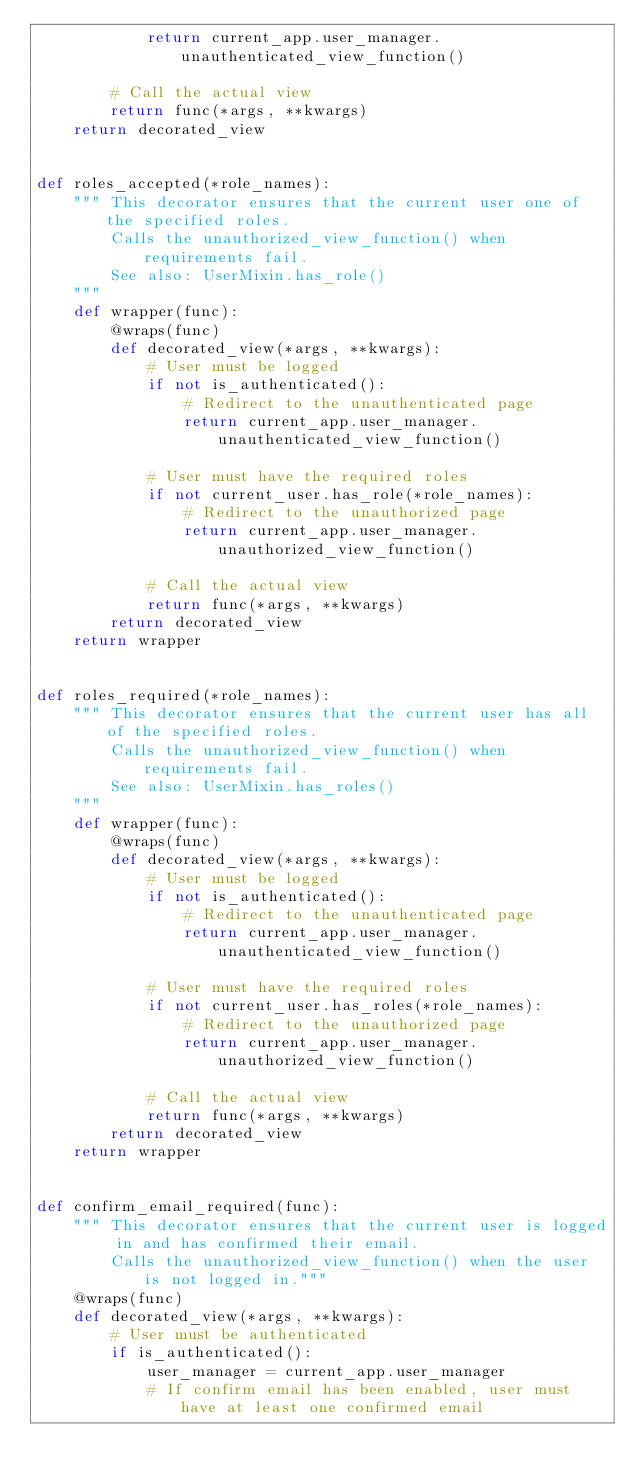<code> <loc_0><loc_0><loc_500><loc_500><_Python_>            return current_app.user_manager.unauthenticated_view_function()

        # Call the actual view
        return func(*args, **kwargs)
    return decorated_view


def roles_accepted(*role_names):
    """ This decorator ensures that the current user one of the specified roles.
        Calls the unauthorized_view_function() when requirements fail.
        See also: UserMixin.has_role()
    """
    def wrapper(func):
        @wraps(func)
        def decorated_view(*args, **kwargs):
            # User must be logged
            if not is_authenticated():
                # Redirect to the unauthenticated page
                return current_app.user_manager.unauthenticated_view_function()

            # User must have the required roles
            if not current_user.has_role(*role_names):
                # Redirect to the unauthorized page
                return current_app.user_manager.unauthorized_view_function()

            # Call the actual view
            return func(*args, **kwargs)
        return decorated_view
    return wrapper


def roles_required(*role_names):
    """ This decorator ensures that the current user has all of the specified roles.
        Calls the unauthorized_view_function() when requirements fail.
        See also: UserMixin.has_roles()
    """
    def wrapper(func):
        @wraps(func)
        def decorated_view(*args, **kwargs):
            # User must be logged
            if not is_authenticated():
                # Redirect to the unauthenticated page
                return current_app.user_manager.unauthenticated_view_function()

            # User must have the required roles
            if not current_user.has_roles(*role_names):
                # Redirect to the unauthorized page
                return current_app.user_manager.unauthorized_view_function()

            # Call the actual view
            return func(*args, **kwargs)
        return decorated_view
    return wrapper


def confirm_email_required(func):
    """ This decorator ensures that the current user is logged in and has confirmed their email.
        Calls the unauthorized_view_function() when the user is not logged in."""
    @wraps(func)
    def decorated_view(*args, **kwargs):
        # User must be authenticated
        if is_authenticated():
            user_manager = current_app.user_manager
            # If confirm email has been enabled, user must have at least one confirmed email</code> 